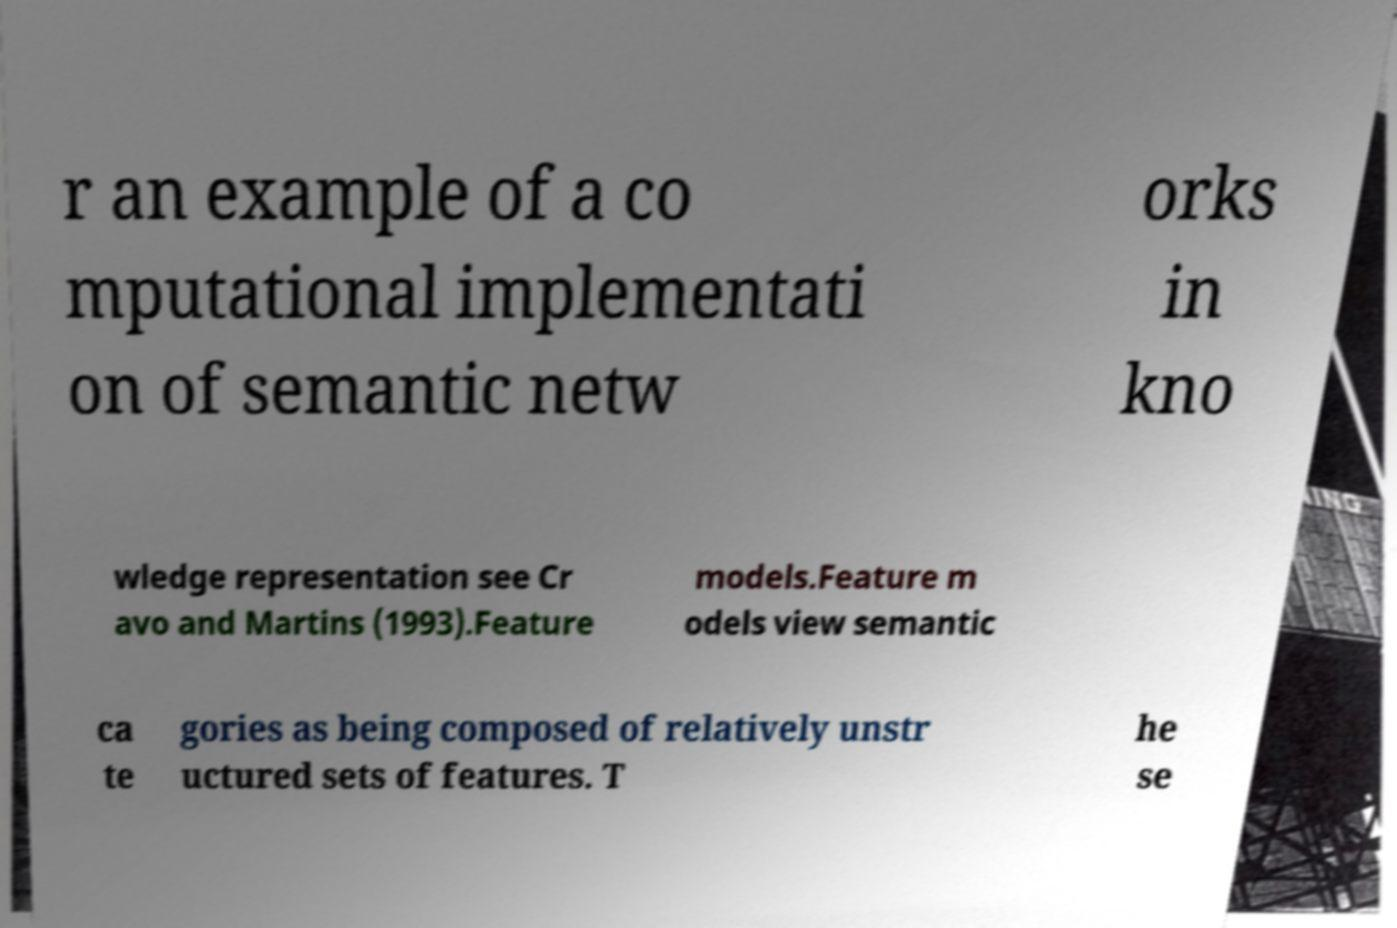Can you accurately transcribe the text from the provided image for me? r an example of a co mputational implementati on of semantic netw orks in kno wledge representation see Cr avo and Martins (1993).Feature models.Feature m odels view semantic ca te gories as being composed of relatively unstr uctured sets of features. T he se 